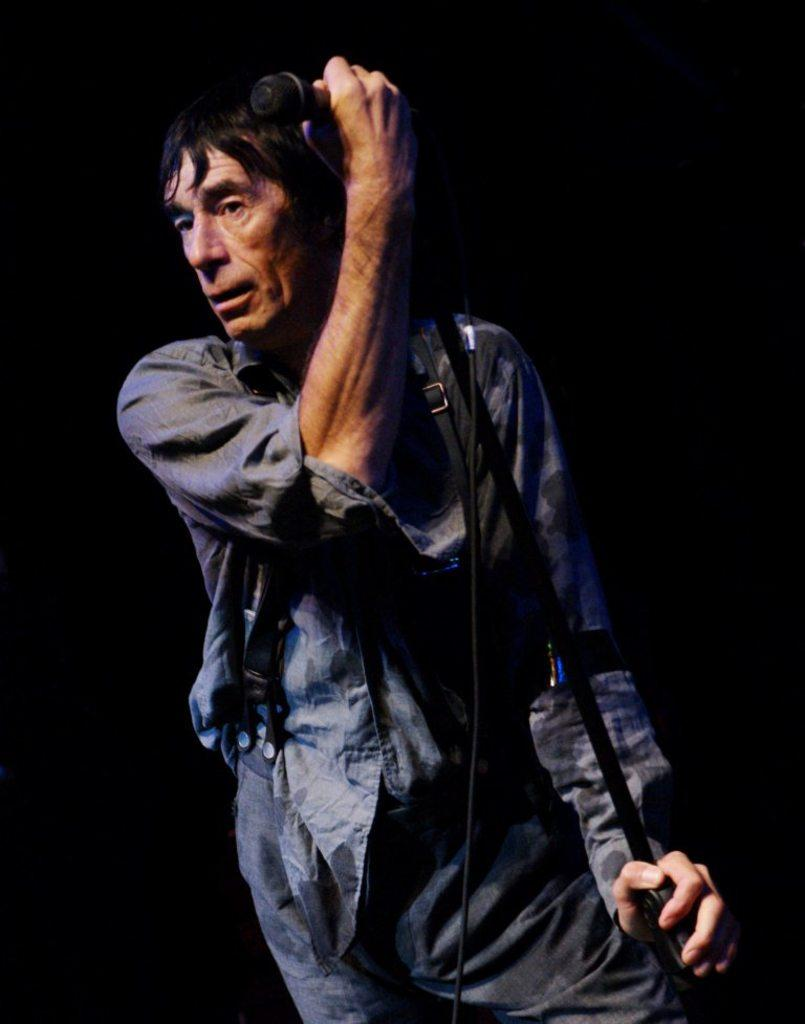What is the man in the image holding? The man is holding a microphone and a stand. What is the man doing with the microphone and stand? The man has his hands on the microphone and stand. Can you describe the man's position or posture in the image? The provided facts do not give information about the man's position or posture. What type of pear is being used as a brake in the image? There is no pear or brake present in the image. 